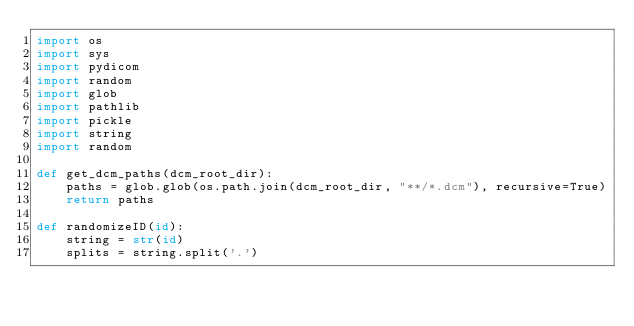<code> <loc_0><loc_0><loc_500><loc_500><_Python_>import os
import sys
import pydicom
import random
import glob
import pathlib
import pickle
import string
import random 

def get_dcm_paths(dcm_root_dir):
    paths = glob.glob(os.path.join(dcm_root_dir, "**/*.dcm"), recursive=True)
    return paths

def randomizeID(id):
    string = str(id)
    splits = string.split('.')</code> 